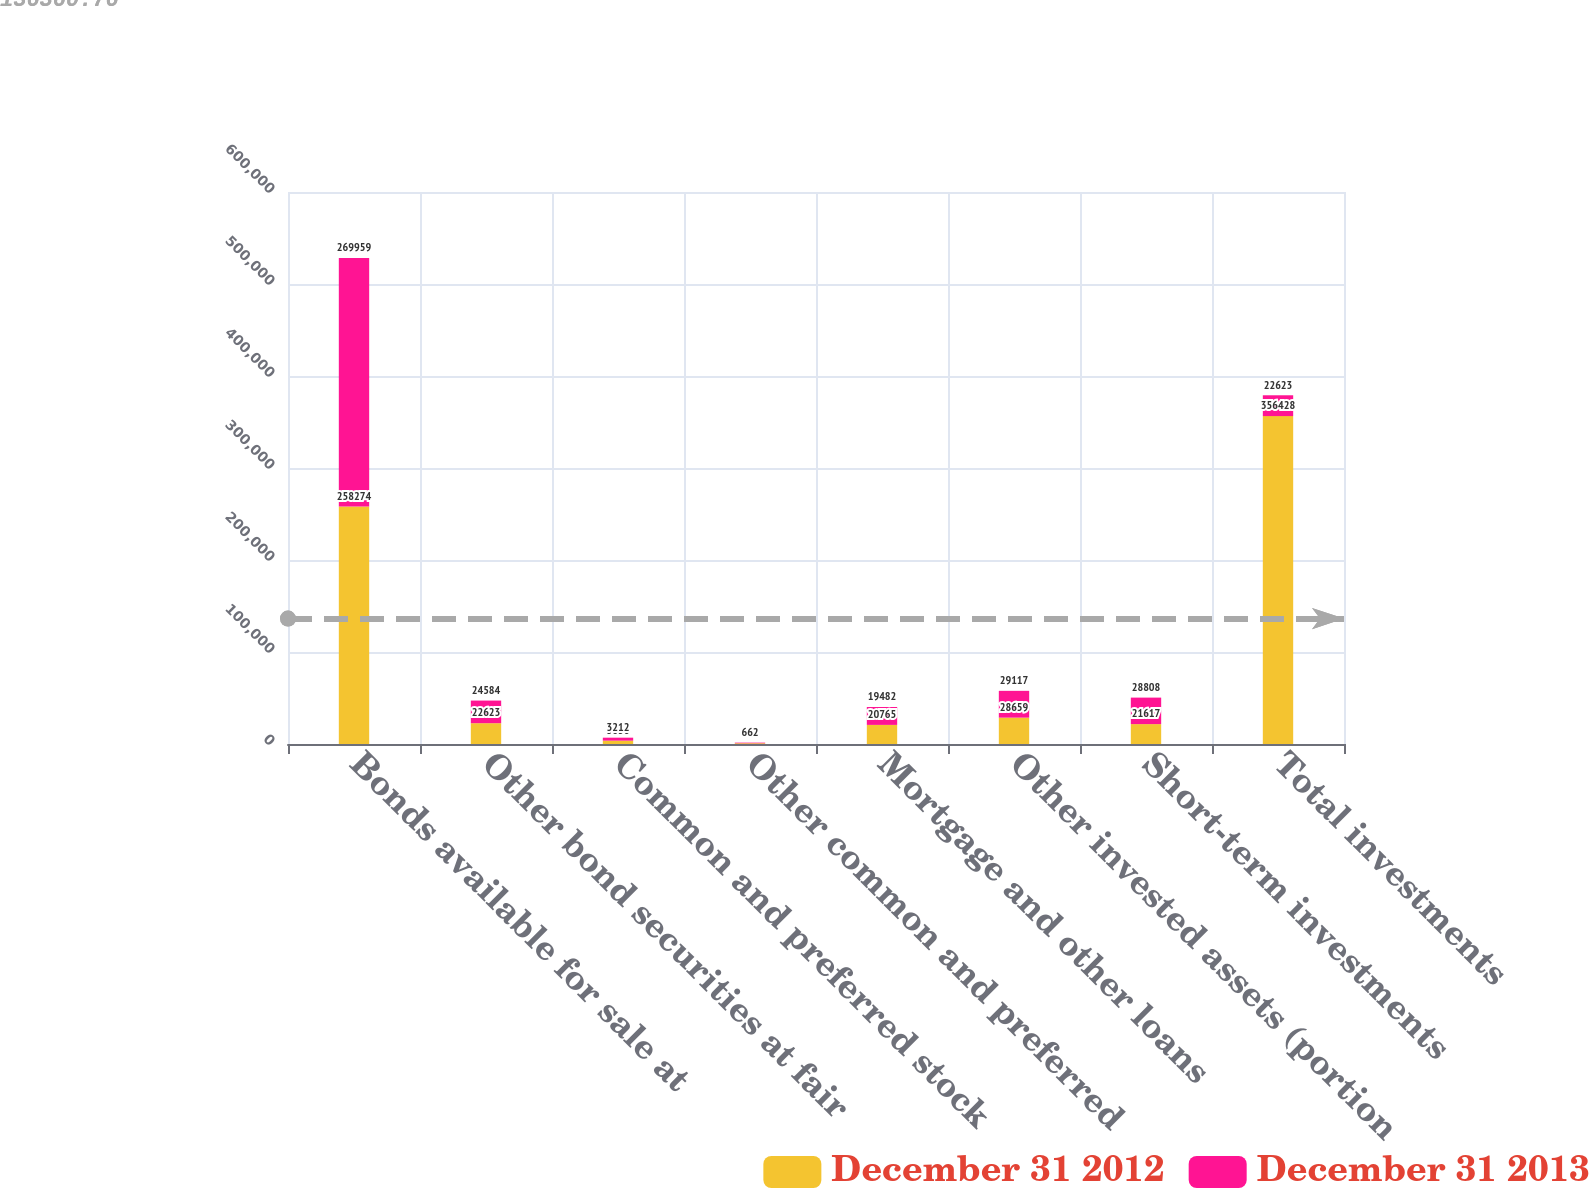<chart> <loc_0><loc_0><loc_500><loc_500><stacked_bar_chart><ecel><fcel>Bonds available for sale at<fcel>Other bond securities at fair<fcel>Common and preferred stock<fcel>Other common and preferred<fcel>Mortgage and other loans<fcel>Other invested assets (portion<fcel>Short-term investments<fcel>Total investments<nl><fcel>December 31 2012<fcel>258274<fcel>22623<fcel>3656<fcel>834<fcel>20765<fcel>28659<fcel>21617<fcel>356428<nl><fcel>December 31 2013<fcel>269959<fcel>24584<fcel>3212<fcel>662<fcel>19482<fcel>29117<fcel>28808<fcel>22623<nl></chart> 